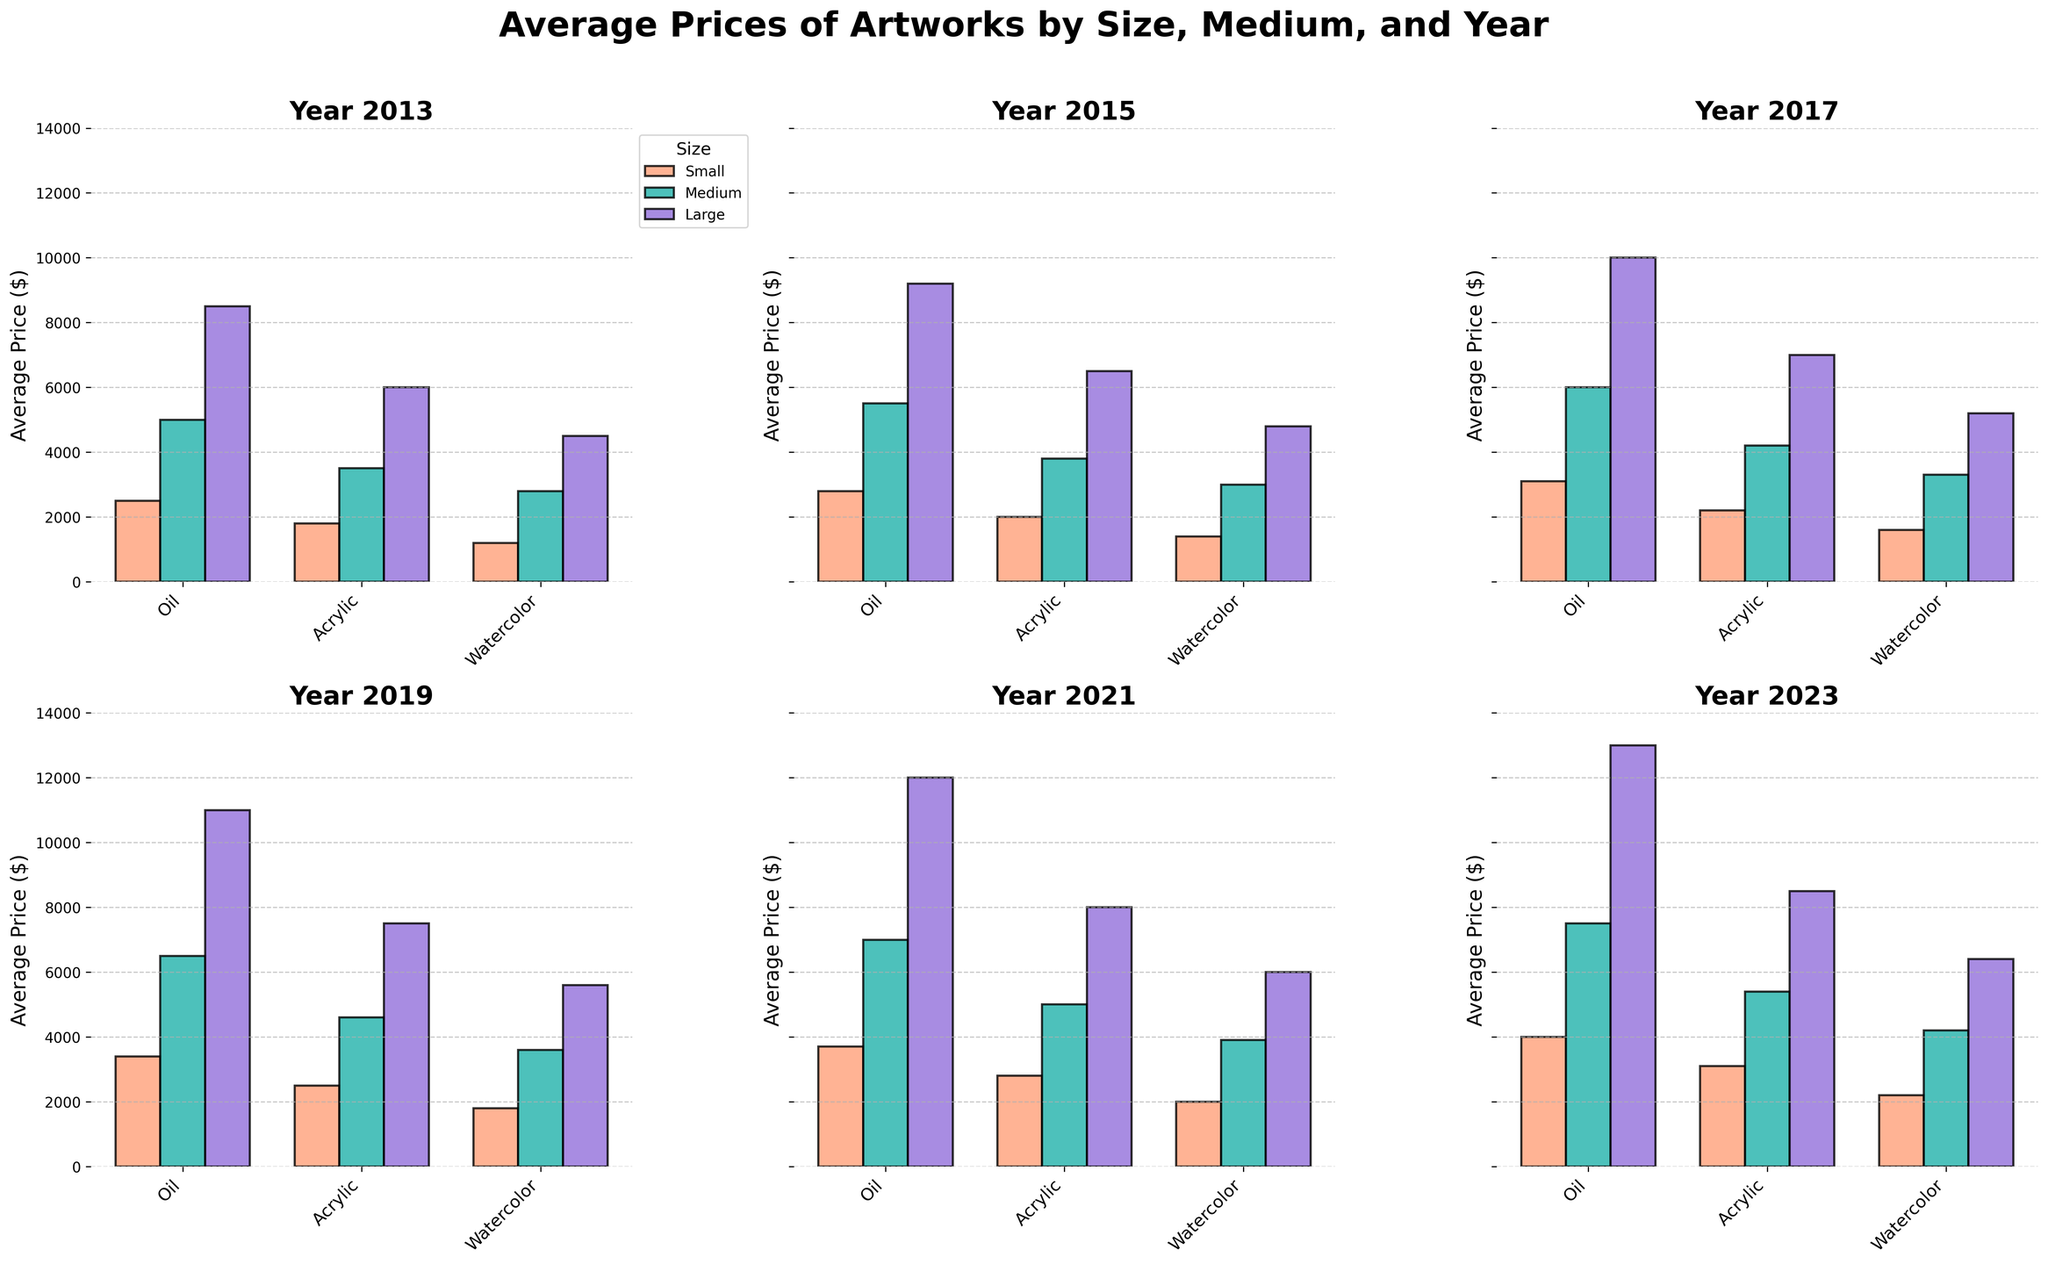what trend can be observed in the average prices of large oil artworks over the decade? The average prices of large oil artworks have shown a consistent increase every year. Starting from $8,500 in 2013, incrementally rising to $13,000 by 2023
Answer: increase which medium saw the highest average price in the most recent year? In the year 2023, the highest average price was observed in large oil artworks with a price of $13,000
Answer: oil how does the average price of small acrylic artworks in 2017 compare to that in 2019? The average price of small acrylic artworks increased from $2,200 in 2017 to $2,500 in 2019
Answer: increase what is the difference between the average prices of medium watercolor artworks and small oil artworks in 2021? In 2021, medium watercolor artworks averaged $3,900 and small oil artworks averaged $3,700. The difference is $3,900 - $3,700 = $200
Answer: $200 in 2015, which size and medium had the smallest average price? In 2015, the smallest average price was for small watercolor artworks, which was $1,400
Answer: small watercolor how do the trends of average prices for small artworks in all mediums compare from 2013 to 2023? The average prices for small artworks in all mediums show an upward trend. For small oil artworks, it increased from $2,500 to $4,000. For small acrylic artworks, it rose from $1,800 to $3,100. Small watercolor artworks saw a rise from $1,200 to $2,200
Answer: upward which year had the highest combined average price for medium-sized oil and acrylic artworks? By summing the average prices for medium oil and acrylic artworks for each year, we find that 2023 had the highest combined price: $7,500 (oil) + $5,400 (acrylic) = $12,900
Answer: 2023 how does the average price increase for large acrylic artworks compare between two consecutive years, 2017 and 2019? The average price for large acrylic artworks increased from $7,000 in 2017 to $7,500 in 2019, a difference of $500
Answer: $500 is there a year where the average price of large watercolor artworks surpassed that of medium oil artworks, and if so, which year? In 2023, the average price for large watercolor artworks was $6,400, which surpassed the average price for medium oil artworks of $7,500
Answer: no 